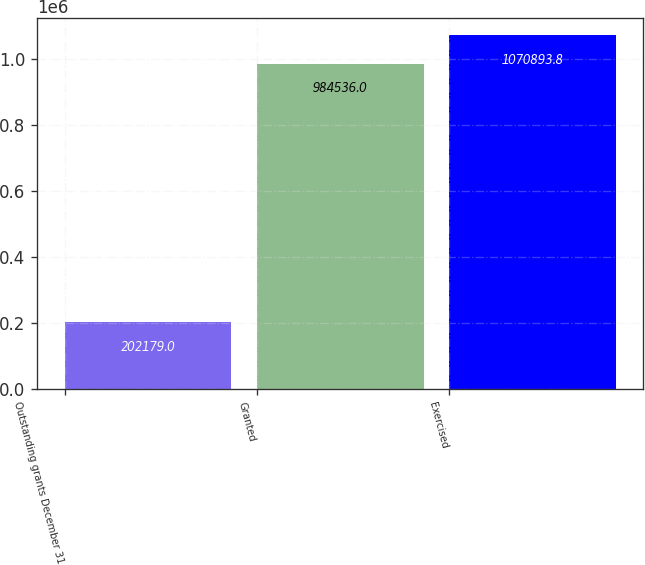Convert chart. <chart><loc_0><loc_0><loc_500><loc_500><bar_chart><fcel>Outstanding grants December 31<fcel>Granted<fcel>Exercised<nl><fcel>202179<fcel>984536<fcel>1.07089e+06<nl></chart> 